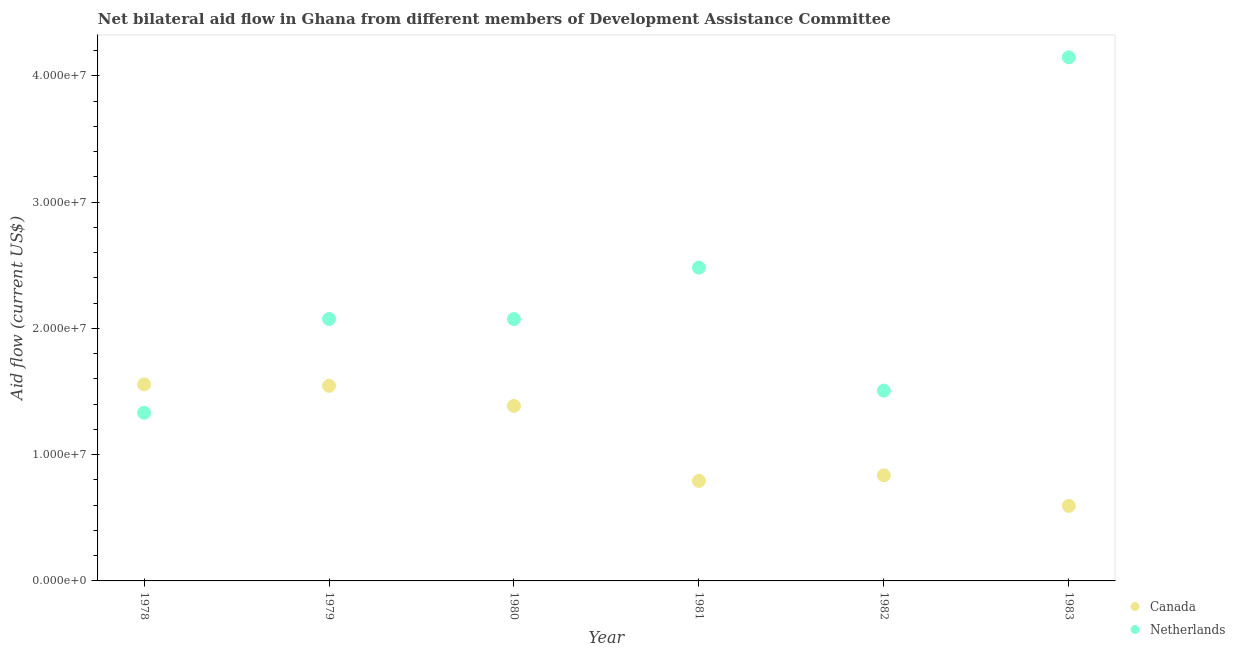What is the amount of aid given by netherlands in 1981?
Your answer should be compact. 2.48e+07. Across all years, what is the maximum amount of aid given by canada?
Provide a succinct answer. 1.56e+07. Across all years, what is the minimum amount of aid given by netherlands?
Your answer should be very brief. 1.33e+07. In which year was the amount of aid given by netherlands maximum?
Make the answer very short. 1983. What is the total amount of aid given by netherlands in the graph?
Your answer should be compact. 1.36e+08. What is the difference between the amount of aid given by canada in 1981 and that in 1982?
Your answer should be compact. -4.40e+05. What is the difference between the amount of aid given by canada in 1982 and the amount of aid given by netherlands in 1980?
Give a very brief answer. -1.24e+07. What is the average amount of aid given by canada per year?
Your answer should be very brief. 1.12e+07. In the year 1980, what is the difference between the amount of aid given by netherlands and amount of aid given by canada?
Provide a short and direct response. 6.87e+06. What is the ratio of the amount of aid given by netherlands in 1978 to that in 1983?
Offer a very short reply. 0.32. What is the difference between the highest and the second highest amount of aid given by canada?
Offer a terse response. 1.10e+05. What is the difference between the highest and the lowest amount of aid given by netherlands?
Offer a very short reply. 2.82e+07. In how many years, is the amount of aid given by canada greater than the average amount of aid given by canada taken over all years?
Your answer should be very brief. 3. Is the amount of aid given by netherlands strictly greater than the amount of aid given by canada over the years?
Provide a short and direct response. No. Is the amount of aid given by netherlands strictly less than the amount of aid given by canada over the years?
Ensure brevity in your answer.  No. How many dotlines are there?
Your answer should be very brief. 2. How many years are there in the graph?
Your answer should be compact. 6. What is the difference between two consecutive major ticks on the Y-axis?
Offer a very short reply. 1.00e+07. Are the values on the major ticks of Y-axis written in scientific E-notation?
Provide a short and direct response. Yes. Does the graph contain any zero values?
Your answer should be compact. No. Does the graph contain grids?
Offer a terse response. No. Where does the legend appear in the graph?
Offer a terse response. Bottom right. How many legend labels are there?
Provide a succinct answer. 2. What is the title of the graph?
Your answer should be compact. Net bilateral aid flow in Ghana from different members of Development Assistance Committee. Does "Official aid received" appear as one of the legend labels in the graph?
Make the answer very short. No. What is the label or title of the X-axis?
Your answer should be compact. Year. What is the Aid flow (current US$) of Canada in 1978?
Give a very brief answer. 1.56e+07. What is the Aid flow (current US$) in Netherlands in 1978?
Your answer should be compact. 1.33e+07. What is the Aid flow (current US$) of Canada in 1979?
Ensure brevity in your answer.  1.54e+07. What is the Aid flow (current US$) in Netherlands in 1979?
Ensure brevity in your answer.  2.07e+07. What is the Aid flow (current US$) in Canada in 1980?
Ensure brevity in your answer.  1.39e+07. What is the Aid flow (current US$) in Netherlands in 1980?
Ensure brevity in your answer.  2.07e+07. What is the Aid flow (current US$) in Canada in 1981?
Your answer should be compact. 7.92e+06. What is the Aid flow (current US$) of Netherlands in 1981?
Your answer should be compact. 2.48e+07. What is the Aid flow (current US$) of Canada in 1982?
Ensure brevity in your answer.  8.36e+06. What is the Aid flow (current US$) in Netherlands in 1982?
Your answer should be very brief. 1.51e+07. What is the Aid flow (current US$) of Canada in 1983?
Provide a short and direct response. 5.94e+06. What is the Aid flow (current US$) in Netherlands in 1983?
Provide a succinct answer. 4.15e+07. Across all years, what is the maximum Aid flow (current US$) of Canada?
Your answer should be compact. 1.56e+07. Across all years, what is the maximum Aid flow (current US$) of Netherlands?
Give a very brief answer. 4.15e+07. Across all years, what is the minimum Aid flow (current US$) of Canada?
Your response must be concise. 5.94e+06. Across all years, what is the minimum Aid flow (current US$) in Netherlands?
Offer a very short reply. 1.33e+07. What is the total Aid flow (current US$) in Canada in the graph?
Offer a terse response. 6.71e+07. What is the total Aid flow (current US$) in Netherlands in the graph?
Your answer should be compact. 1.36e+08. What is the difference between the Aid flow (current US$) of Netherlands in 1978 and that in 1979?
Offer a very short reply. -7.43e+06. What is the difference between the Aid flow (current US$) in Canada in 1978 and that in 1980?
Ensure brevity in your answer.  1.70e+06. What is the difference between the Aid flow (current US$) of Netherlands in 1978 and that in 1980?
Give a very brief answer. -7.42e+06. What is the difference between the Aid flow (current US$) of Canada in 1978 and that in 1981?
Provide a short and direct response. 7.64e+06. What is the difference between the Aid flow (current US$) of Netherlands in 1978 and that in 1981?
Make the answer very short. -1.15e+07. What is the difference between the Aid flow (current US$) of Canada in 1978 and that in 1982?
Your answer should be very brief. 7.20e+06. What is the difference between the Aid flow (current US$) of Netherlands in 1978 and that in 1982?
Give a very brief answer. -1.76e+06. What is the difference between the Aid flow (current US$) of Canada in 1978 and that in 1983?
Your answer should be very brief. 9.62e+06. What is the difference between the Aid flow (current US$) of Netherlands in 1978 and that in 1983?
Make the answer very short. -2.82e+07. What is the difference between the Aid flow (current US$) of Canada in 1979 and that in 1980?
Your answer should be very brief. 1.59e+06. What is the difference between the Aid flow (current US$) in Netherlands in 1979 and that in 1980?
Your answer should be compact. 10000. What is the difference between the Aid flow (current US$) of Canada in 1979 and that in 1981?
Provide a succinct answer. 7.53e+06. What is the difference between the Aid flow (current US$) of Netherlands in 1979 and that in 1981?
Offer a terse response. -4.07e+06. What is the difference between the Aid flow (current US$) of Canada in 1979 and that in 1982?
Offer a very short reply. 7.09e+06. What is the difference between the Aid flow (current US$) in Netherlands in 1979 and that in 1982?
Your response must be concise. 5.67e+06. What is the difference between the Aid flow (current US$) of Canada in 1979 and that in 1983?
Your response must be concise. 9.51e+06. What is the difference between the Aid flow (current US$) of Netherlands in 1979 and that in 1983?
Ensure brevity in your answer.  -2.07e+07. What is the difference between the Aid flow (current US$) in Canada in 1980 and that in 1981?
Make the answer very short. 5.94e+06. What is the difference between the Aid flow (current US$) of Netherlands in 1980 and that in 1981?
Provide a short and direct response. -4.08e+06. What is the difference between the Aid flow (current US$) of Canada in 1980 and that in 1982?
Provide a short and direct response. 5.50e+06. What is the difference between the Aid flow (current US$) in Netherlands in 1980 and that in 1982?
Your answer should be very brief. 5.66e+06. What is the difference between the Aid flow (current US$) of Canada in 1980 and that in 1983?
Your answer should be compact. 7.92e+06. What is the difference between the Aid flow (current US$) of Netherlands in 1980 and that in 1983?
Provide a short and direct response. -2.07e+07. What is the difference between the Aid flow (current US$) in Canada in 1981 and that in 1982?
Provide a succinct answer. -4.40e+05. What is the difference between the Aid flow (current US$) of Netherlands in 1981 and that in 1982?
Your answer should be compact. 9.74e+06. What is the difference between the Aid flow (current US$) of Canada in 1981 and that in 1983?
Your response must be concise. 1.98e+06. What is the difference between the Aid flow (current US$) in Netherlands in 1981 and that in 1983?
Keep it short and to the point. -1.66e+07. What is the difference between the Aid flow (current US$) in Canada in 1982 and that in 1983?
Give a very brief answer. 2.42e+06. What is the difference between the Aid flow (current US$) in Netherlands in 1982 and that in 1983?
Make the answer very short. -2.64e+07. What is the difference between the Aid flow (current US$) in Canada in 1978 and the Aid flow (current US$) in Netherlands in 1979?
Provide a short and direct response. -5.18e+06. What is the difference between the Aid flow (current US$) of Canada in 1978 and the Aid flow (current US$) of Netherlands in 1980?
Your answer should be very brief. -5.17e+06. What is the difference between the Aid flow (current US$) of Canada in 1978 and the Aid flow (current US$) of Netherlands in 1981?
Offer a very short reply. -9.25e+06. What is the difference between the Aid flow (current US$) in Canada in 1978 and the Aid flow (current US$) in Netherlands in 1983?
Offer a very short reply. -2.59e+07. What is the difference between the Aid flow (current US$) in Canada in 1979 and the Aid flow (current US$) in Netherlands in 1980?
Give a very brief answer. -5.28e+06. What is the difference between the Aid flow (current US$) in Canada in 1979 and the Aid flow (current US$) in Netherlands in 1981?
Make the answer very short. -9.36e+06. What is the difference between the Aid flow (current US$) in Canada in 1979 and the Aid flow (current US$) in Netherlands in 1982?
Your answer should be very brief. 3.80e+05. What is the difference between the Aid flow (current US$) of Canada in 1979 and the Aid flow (current US$) of Netherlands in 1983?
Provide a short and direct response. -2.60e+07. What is the difference between the Aid flow (current US$) in Canada in 1980 and the Aid flow (current US$) in Netherlands in 1981?
Your response must be concise. -1.10e+07. What is the difference between the Aid flow (current US$) in Canada in 1980 and the Aid flow (current US$) in Netherlands in 1982?
Your answer should be compact. -1.21e+06. What is the difference between the Aid flow (current US$) of Canada in 1980 and the Aid flow (current US$) of Netherlands in 1983?
Give a very brief answer. -2.76e+07. What is the difference between the Aid flow (current US$) of Canada in 1981 and the Aid flow (current US$) of Netherlands in 1982?
Give a very brief answer. -7.15e+06. What is the difference between the Aid flow (current US$) in Canada in 1981 and the Aid flow (current US$) in Netherlands in 1983?
Offer a terse response. -3.35e+07. What is the difference between the Aid flow (current US$) in Canada in 1982 and the Aid flow (current US$) in Netherlands in 1983?
Your answer should be compact. -3.31e+07. What is the average Aid flow (current US$) in Canada per year?
Your answer should be very brief. 1.12e+07. What is the average Aid flow (current US$) in Netherlands per year?
Your response must be concise. 2.27e+07. In the year 1978, what is the difference between the Aid flow (current US$) in Canada and Aid flow (current US$) in Netherlands?
Your answer should be compact. 2.25e+06. In the year 1979, what is the difference between the Aid flow (current US$) of Canada and Aid flow (current US$) of Netherlands?
Offer a very short reply. -5.29e+06. In the year 1980, what is the difference between the Aid flow (current US$) in Canada and Aid flow (current US$) in Netherlands?
Your response must be concise. -6.87e+06. In the year 1981, what is the difference between the Aid flow (current US$) of Canada and Aid flow (current US$) of Netherlands?
Give a very brief answer. -1.69e+07. In the year 1982, what is the difference between the Aid flow (current US$) in Canada and Aid flow (current US$) in Netherlands?
Make the answer very short. -6.71e+06. In the year 1983, what is the difference between the Aid flow (current US$) of Canada and Aid flow (current US$) of Netherlands?
Keep it short and to the point. -3.55e+07. What is the ratio of the Aid flow (current US$) of Canada in 1978 to that in 1979?
Ensure brevity in your answer.  1.01. What is the ratio of the Aid flow (current US$) in Netherlands in 1978 to that in 1979?
Ensure brevity in your answer.  0.64. What is the ratio of the Aid flow (current US$) in Canada in 1978 to that in 1980?
Offer a very short reply. 1.12. What is the ratio of the Aid flow (current US$) in Netherlands in 1978 to that in 1980?
Provide a succinct answer. 0.64. What is the ratio of the Aid flow (current US$) in Canada in 1978 to that in 1981?
Provide a short and direct response. 1.96. What is the ratio of the Aid flow (current US$) of Netherlands in 1978 to that in 1981?
Your answer should be very brief. 0.54. What is the ratio of the Aid flow (current US$) in Canada in 1978 to that in 1982?
Offer a terse response. 1.86. What is the ratio of the Aid flow (current US$) of Netherlands in 1978 to that in 1982?
Offer a terse response. 0.88. What is the ratio of the Aid flow (current US$) in Canada in 1978 to that in 1983?
Your response must be concise. 2.62. What is the ratio of the Aid flow (current US$) of Netherlands in 1978 to that in 1983?
Offer a very short reply. 0.32. What is the ratio of the Aid flow (current US$) in Canada in 1979 to that in 1980?
Provide a succinct answer. 1.11. What is the ratio of the Aid flow (current US$) in Canada in 1979 to that in 1981?
Provide a succinct answer. 1.95. What is the ratio of the Aid flow (current US$) of Netherlands in 1979 to that in 1981?
Make the answer very short. 0.84. What is the ratio of the Aid flow (current US$) of Canada in 1979 to that in 1982?
Offer a very short reply. 1.85. What is the ratio of the Aid flow (current US$) of Netherlands in 1979 to that in 1982?
Offer a terse response. 1.38. What is the ratio of the Aid flow (current US$) of Canada in 1979 to that in 1983?
Your response must be concise. 2.6. What is the ratio of the Aid flow (current US$) in Netherlands in 1979 to that in 1983?
Provide a succinct answer. 0.5. What is the ratio of the Aid flow (current US$) of Canada in 1980 to that in 1981?
Ensure brevity in your answer.  1.75. What is the ratio of the Aid flow (current US$) in Netherlands in 1980 to that in 1981?
Provide a succinct answer. 0.84. What is the ratio of the Aid flow (current US$) in Canada in 1980 to that in 1982?
Your answer should be compact. 1.66. What is the ratio of the Aid flow (current US$) in Netherlands in 1980 to that in 1982?
Provide a short and direct response. 1.38. What is the ratio of the Aid flow (current US$) of Canada in 1980 to that in 1983?
Keep it short and to the point. 2.33. What is the ratio of the Aid flow (current US$) of Netherlands in 1981 to that in 1982?
Offer a very short reply. 1.65. What is the ratio of the Aid flow (current US$) of Netherlands in 1981 to that in 1983?
Keep it short and to the point. 0.6. What is the ratio of the Aid flow (current US$) in Canada in 1982 to that in 1983?
Make the answer very short. 1.41. What is the ratio of the Aid flow (current US$) in Netherlands in 1982 to that in 1983?
Offer a very short reply. 0.36. What is the difference between the highest and the second highest Aid flow (current US$) in Netherlands?
Give a very brief answer. 1.66e+07. What is the difference between the highest and the lowest Aid flow (current US$) of Canada?
Offer a terse response. 9.62e+06. What is the difference between the highest and the lowest Aid flow (current US$) in Netherlands?
Offer a very short reply. 2.82e+07. 